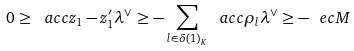<formula> <loc_0><loc_0><loc_500><loc_500>0 \geq \ a c c { z _ { 1 } - z ^ { \prime } _ { 1 } } { \lambda ^ { \vee } } \geq - \sum _ { l \in \delta ( 1 ) _ { K } } \ a c c { \rho _ { l } } { \lambda ^ { \vee } } \geq - \ e c M</formula> 